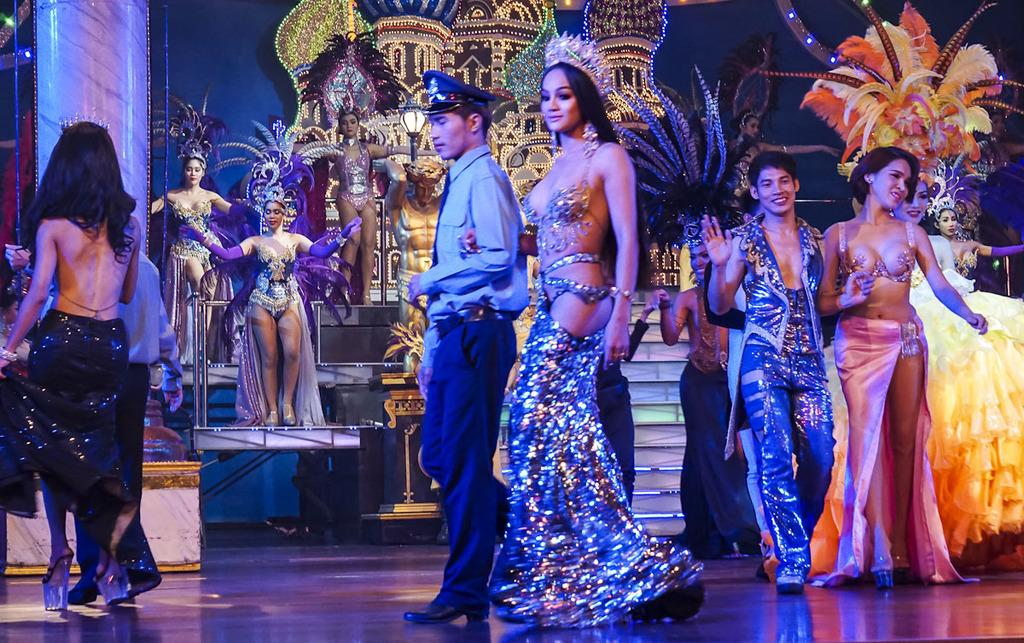How many people are in the image? There are persons in the image, but the exact number cannot be determined from the provided facts. What is the primary surface visible in the image? The image shows a floor. What can be seen in the background of the image? There is a wall visible in the background of the image. What is the condition of the thread used to sew the hour on the wall in the image? There is no thread or hour mentioned in the image, so this question cannot be answered. 